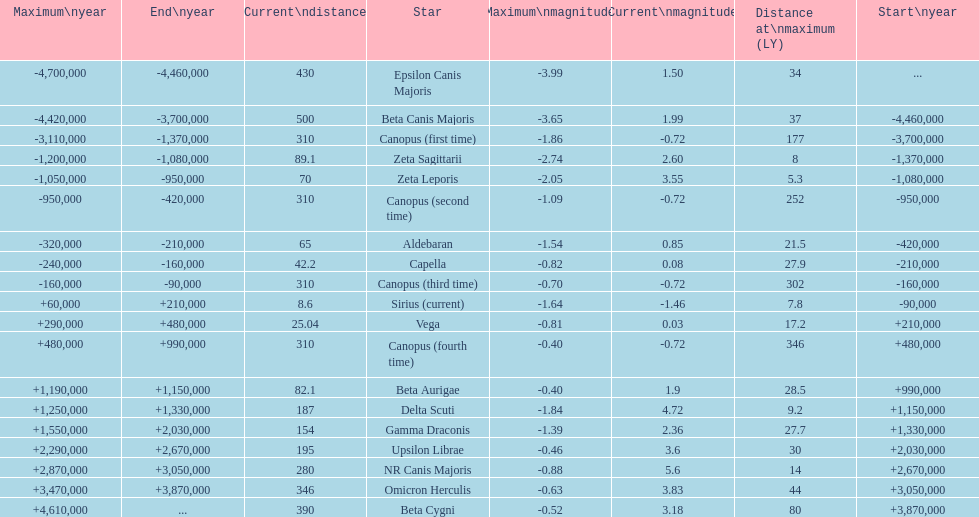What is the number of stars that have a maximum magnitude less than zero? 5. Parse the table in full. {'header': ['Maximum\\nyear', 'End\\nyear', 'Current\\ndistance', 'Star', 'Maximum\\nmagnitude', 'Current\\nmagnitude', 'Distance at\\nmaximum (LY)', 'Start\\nyear'], 'rows': [['-4,700,000', '-4,460,000', '430', 'Epsilon Canis Majoris', '-3.99', '1.50', '34', '...'], ['-4,420,000', '-3,700,000', '500', 'Beta Canis Majoris', '-3.65', '1.99', '37', '-4,460,000'], ['-3,110,000', '-1,370,000', '310', 'Canopus (first time)', '-1.86', '-0.72', '177', '-3,700,000'], ['-1,200,000', '-1,080,000', '89.1', 'Zeta Sagittarii', '-2.74', '2.60', '8', '-1,370,000'], ['-1,050,000', '-950,000', '70', 'Zeta Leporis', '-2.05', '3.55', '5.3', '-1,080,000'], ['-950,000', '-420,000', '310', 'Canopus (second time)', '-1.09', '-0.72', '252', '-950,000'], ['-320,000', '-210,000', '65', 'Aldebaran', '-1.54', '0.85', '21.5', '-420,000'], ['-240,000', '-160,000', '42.2', 'Capella', '-0.82', '0.08', '27.9', '-210,000'], ['-160,000', '-90,000', '310', 'Canopus (third time)', '-0.70', '-0.72', '302', '-160,000'], ['+60,000', '+210,000', '8.6', 'Sirius (current)', '-1.64', '-1.46', '7.8', '-90,000'], ['+290,000', '+480,000', '25.04', 'Vega', '-0.81', '0.03', '17.2', '+210,000'], ['+480,000', '+990,000', '310', 'Canopus (fourth time)', '-0.40', '-0.72', '346', '+480,000'], ['+1,190,000', '+1,150,000', '82.1', 'Beta Aurigae', '-0.40', '1.9', '28.5', '+990,000'], ['+1,250,000', '+1,330,000', '187', 'Delta Scuti', '-1.84', '4.72', '9.2', '+1,150,000'], ['+1,550,000', '+2,030,000', '154', 'Gamma Draconis', '-1.39', '2.36', '27.7', '+1,330,000'], ['+2,290,000', '+2,670,000', '195', 'Upsilon Librae', '-0.46', '3.6', '30', '+2,030,000'], ['+2,870,000', '+3,050,000', '280', 'NR Canis Majoris', '-0.88', '5.6', '14', '+2,670,000'], ['+3,470,000', '+3,870,000', '346', 'Omicron Herculis', '-0.63', '3.83', '44', '+3,050,000'], ['+4,610,000', '...', '390', 'Beta Cygni', '-0.52', '3.18', '80', '+3,870,000']]} 